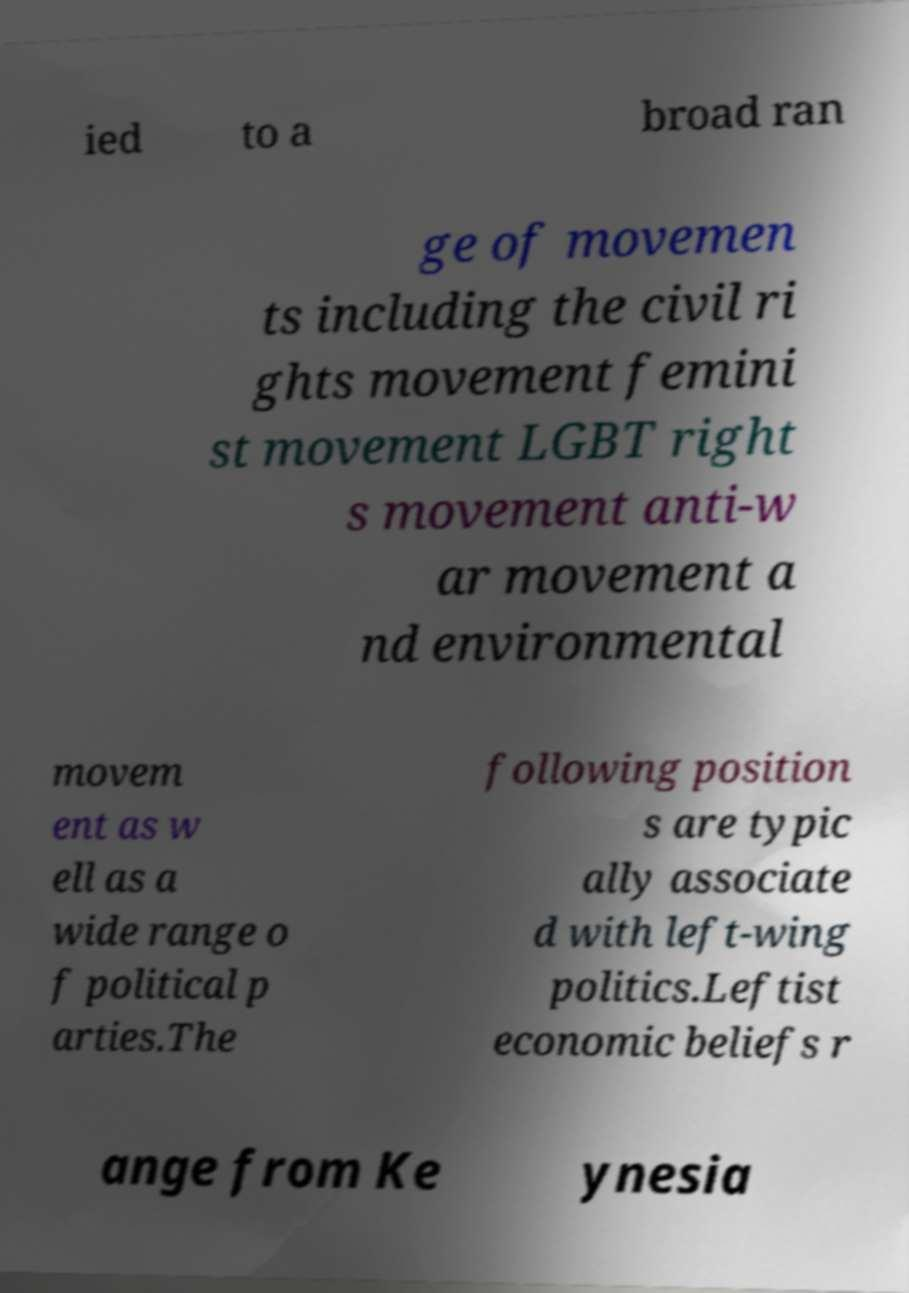Could you assist in decoding the text presented in this image and type it out clearly? ied to a broad ran ge of movemen ts including the civil ri ghts movement femini st movement LGBT right s movement anti-w ar movement a nd environmental movem ent as w ell as a wide range o f political p arties.The following position s are typic ally associate d with left-wing politics.Leftist economic beliefs r ange from Ke ynesia 